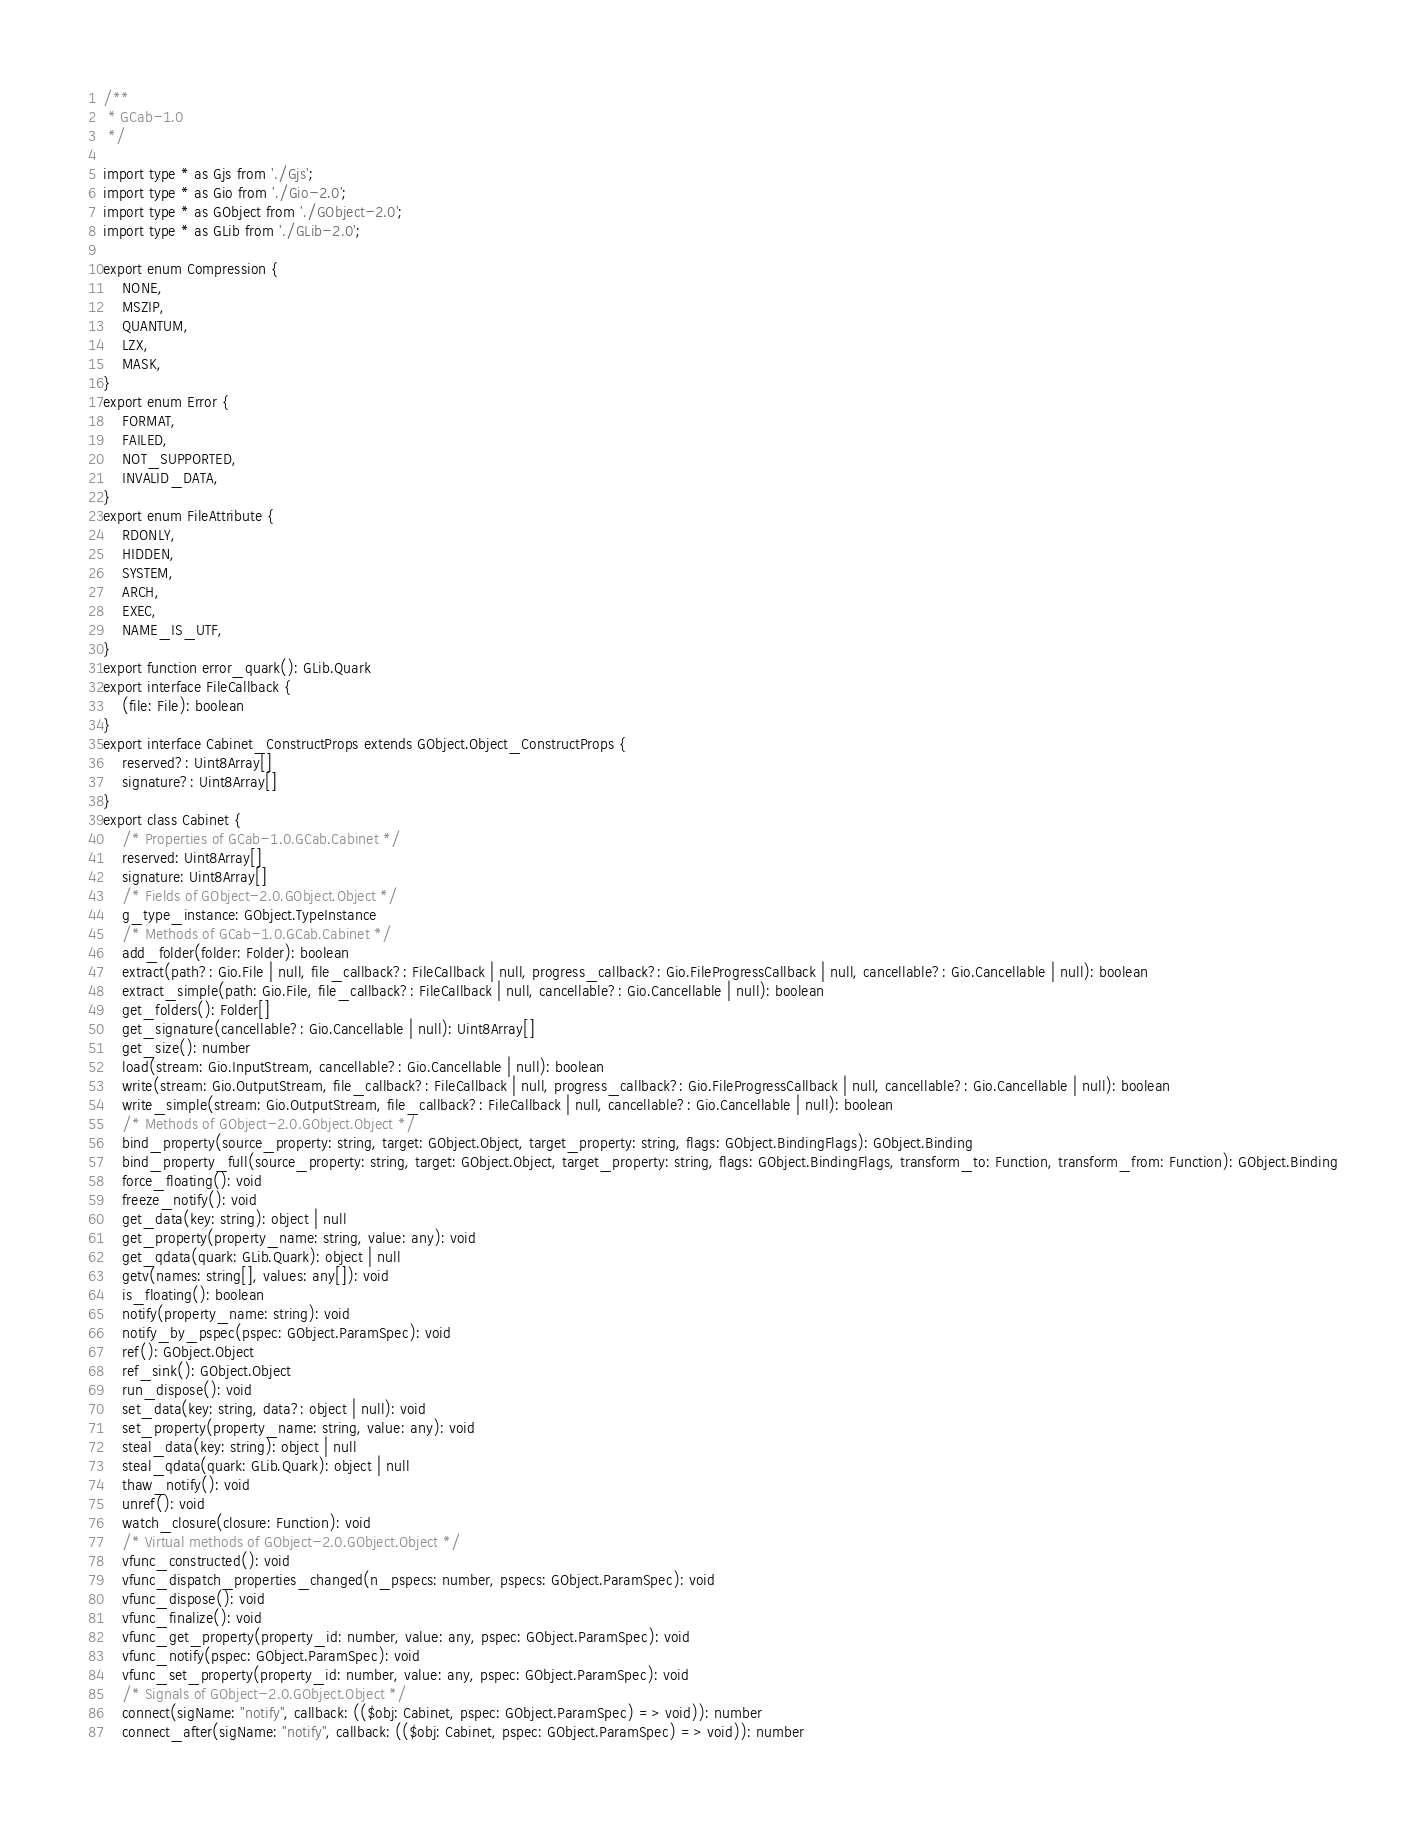<code> <loc_0><loc_0><loc_500><loc_500><_TypeScript_>/**
 * GCab-1.0
 */

import type * as Gjs from './Gjs';
import type * as Gio from './Gio-2.0';
import type * as GObject from './GObject-2.0';
import type * as GLib from './GLib-2.0';

export enum Compression {
    NONE,
    MSZIP,
    QUANTUM,
    LZX,
    MASK,
}
export enum Error {
    FORMAT,
    FAILED,
    NOT_SUPPORTED,
    INVALID_DATA,
}
export enum FileAttribute {
    RDONLY,
    HIDDEN,
    SYSTEM,
    ARCH,
    EXEC,
    NAME_IS_UTF,
}
export function error_quark(): GLib.Quark
export interface FileCallback {
    (file: File): boolean
}
export interface Cabinet_ConstructProps extends GObject.Object_ConstructProps {
    reserved?: Uint8Array[]
    signature?: Uint8Array[]
}
export class Cabinet {
    /* Properties of GCab-1.0.GCab.Cabinet */
    reserved: Uint8Array[]
    signature: Uint8Array[]
    /* Fields of GObject-2.0.GObject.Object */
    g_type_instance: GObject.TypeInstance
    /* Methods of GCab-1.0.GCab.Cabinet */
    add_folder(folder: Folder): boolean
    extract(path?: Gio.File | null, file_callback?: FileCallback | null, progress_callback?: Gio.FileProgressCallback | null, cancellable?: Gio.Cancellable | null): boolean
    extract_simple(path: Gio.File, file_callback?: FileCallback | null, cancellable?: Gio.Cancellable | null): boolean
    get_folders(): Folder[]
    get_signature(cancellable?: Gio.Cancellable | null): Uint8Array[]
    get_size(): number
    load(stream: Gio.InputStream, cancellable?: Gio.Cancellable | null): boolean
    write(stream: Gio.OutputStream, file_callback?: FileCallback | null, progress_callback?: Gio.FileProgressCallback | null, cancellable?: Gio.Cancellable | null): boolean
    write_simple(stream: Gio.OutputStream, file_callback?: FileCallback | null, cancellable?: Gio.Cancellable | null): boolean
    /* Methods of GObject-2.0.GObject.Object */
    bind_property(source_property: string, target: GObject.Object, target_property: string, flags: GObject.BindingFlags): GObject.Binding
    bind_property_full(source_property: string, target: GObject.Object, target_property: string, flags: GObject.BindingFlags, transform_to: Function, transform_from: Function): GObject.Binding
    force_floating(): void
    freeze_notify(): void
    get_data(key: string): object | null
    get_property(property_name: string, value: any): void
    get_qdata(quark: GLib.Quark): object | null
    getv(names: string[], values: any[]): void
    is_floating(): boolean
    notify(property_name: string): void
    notify_by_pspec(pspec: GObject.ParamSpec): void
    ref(): GObject.Object
    ref_sink(): GObject.Object
    run_dispose(): void
    set_data(key: string, data?: object | null): void
    set_property(property_name: string, value: any): void
    steal_data(key: string): object | null
    steal_qdata(quark: GLib.Quark): object | null
    thaw_notify(): void
    unref(): void
    watch_closure(closure: Function): void
    /* Virtual methods of GObject-2.0.GObject.Object */
    vfunc_constructed(): void
    vfunc_dispatch_properties_changed(n_pspecs: number, pspecs: GObject.ParamSpec): void
    vfunc_dispose(): void
    vfunc_finalize(): void
    vfunc_get_property(property_id: number, value: any, pspec: GObject.ParamSpec): void
    vfunc_notify(pspec: GObject.ParamSpec): void
    vfunc_set_property(property_id: number, value: any, pspec: GObject.ParamSpec): void
    /* Signals of GObject-2.0.GObject.Object */
    connect(sigName: "notify", callback: (($obj: Cabinet, pspec: GObject.ParamSpec) => void)): number
    connect_after(sigName: "notify", callback: (($obj: Cabinet, pspec: GObject.ParamSpec) => void)): number</code> 